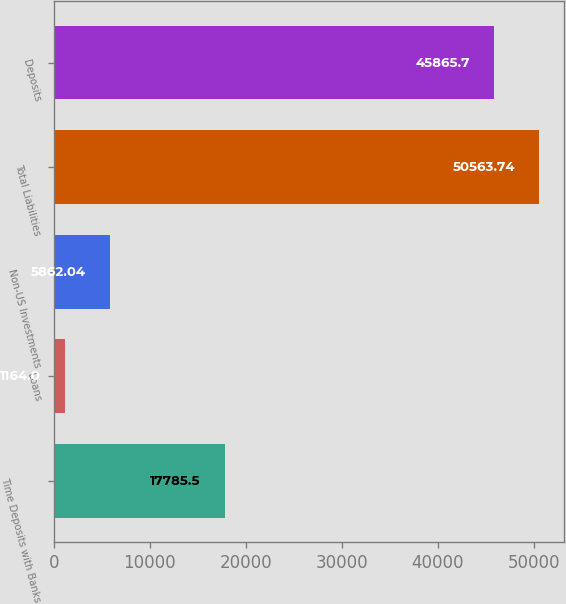Convert chart. <chart><loc_0><loc_0><loc_500><loc_500><bar_chart><fcel>Time Deposits with Banks<fcel>Loans<fcel>Non-US Investments<fcel>Total Liabilities<fcel>Deposits<nl><fcel>17785.5<fcel>1164<fcel>5862.04<fcel>50563.7<fcel>45865.7<nl></chart> 